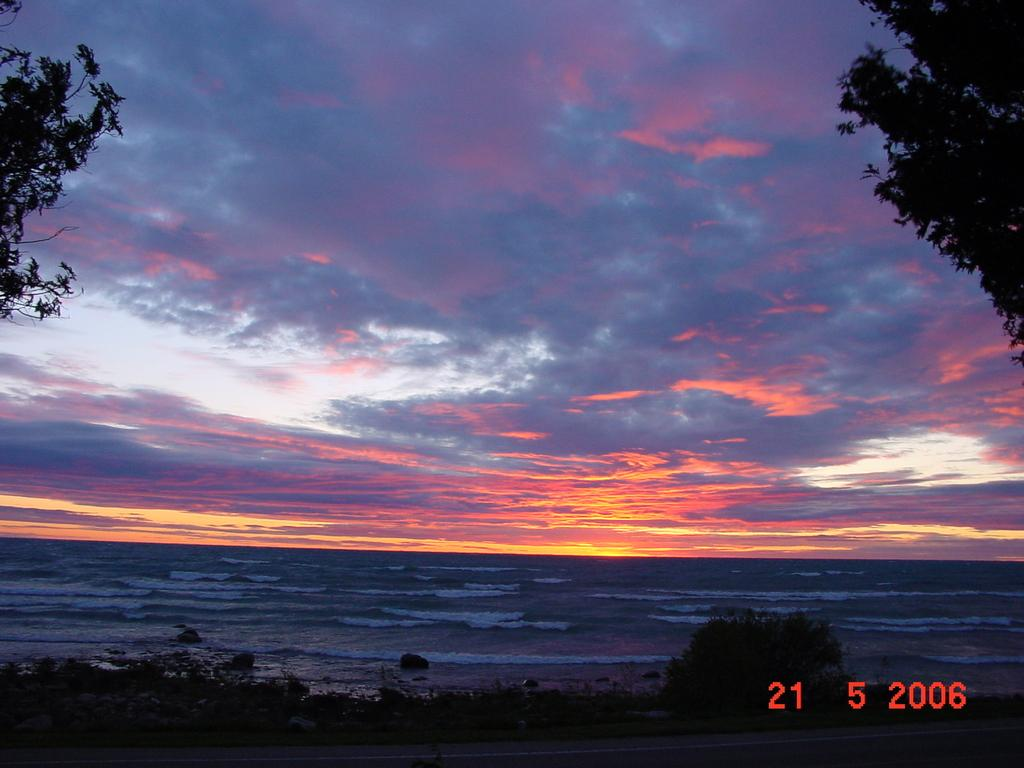What can be seen in the center of the image? The center of the image contains the sky, clouds, trees, and water. Where is the text located in the image? The text is in the bottom right side of the image. How many children are playing in the water in the image? There are no children present in the image; it only features the sky, clouds, trees, and water. What direction is the current flowing in the image? There is no reference to a current in the image, as it only contains the sky, clouds, trees, and water. 